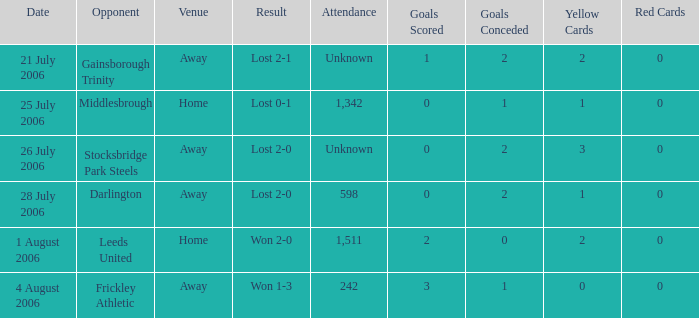What is the attendance rate for the Middlesbrough opponent? 1342.0. 